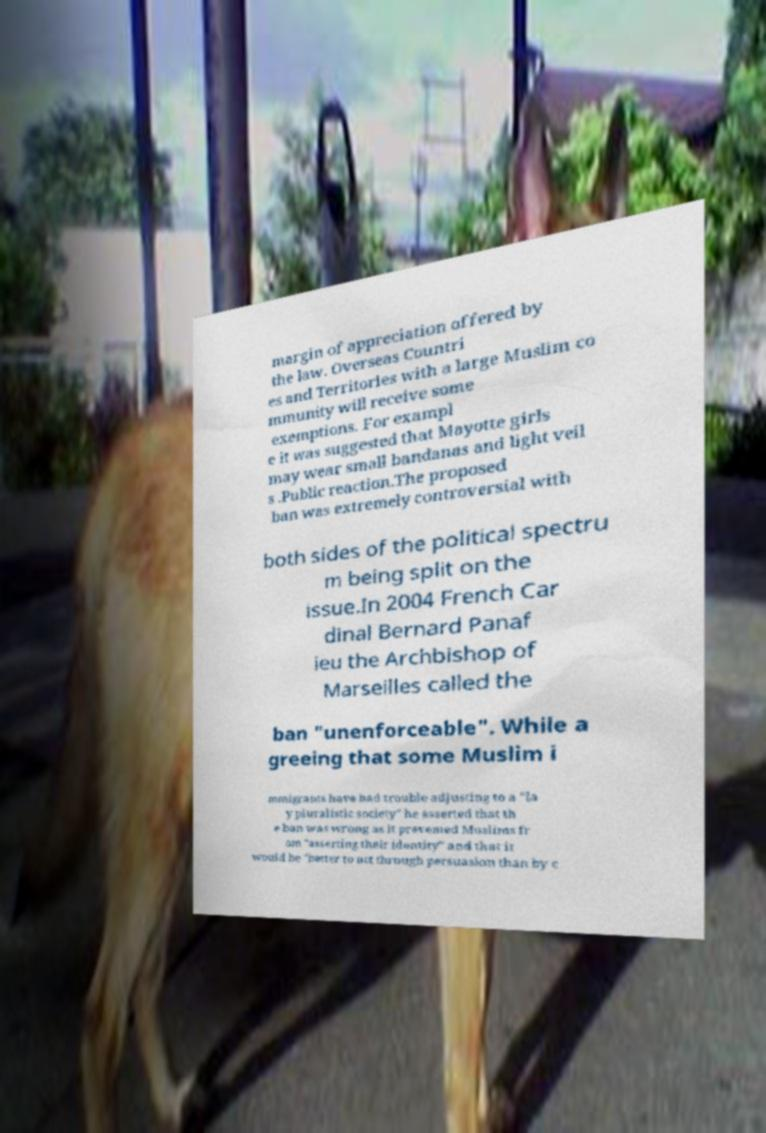Could you assist in decoding the text presented in this image and type it out clearly? margin of appreciation offered by the law. Overseas Countri es and Territories with a large Muslim co mmunity will receive some exemptions. For exampl e it was suggested that Mayotte girls may wear small bandanas and light veil s .Public reaction.The proposed ban was extremely controversial with both sides of the political spectru m being split on the issue.In 2004 French Car dinal Bernard Panaf ieu the Archbishop of Marseilles called the ban "unenforceable". While a greeing that some Muslim i mmigrants have had trouble adjusting to a "la y pluralistic society" he asserted that th e ban was wrong as it prevented Muslims fr om "asserting their identity" and that it would be "better to act through persuasion than by c 